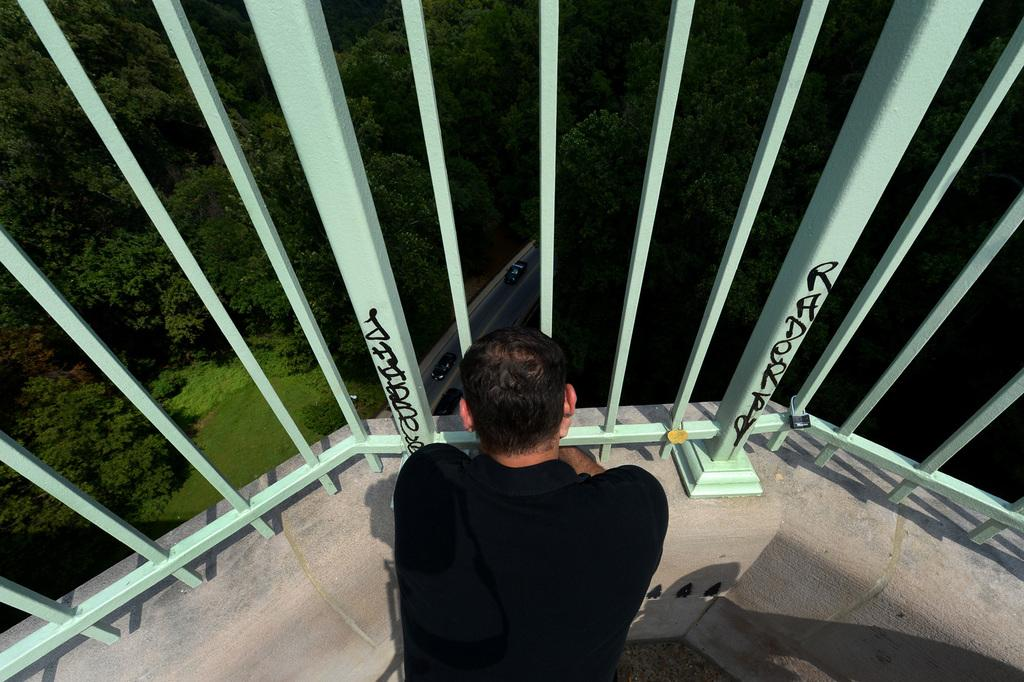What is the person in the image doing? The person is sitting on the floor in the image. What is behind the person in the image? The person is in front of grills. What can be seen in the background of the image? There are trees and motor vehicles visible on the road in the background. What is the surface that the person and grills are on? The ground is visible in the image. What type of skin condition can be seen on the person in the image? There is no indication of a skin condition visible on the person in the image. What is the cause of death for the person in the image? There is no indication of death or any related information in the image. 